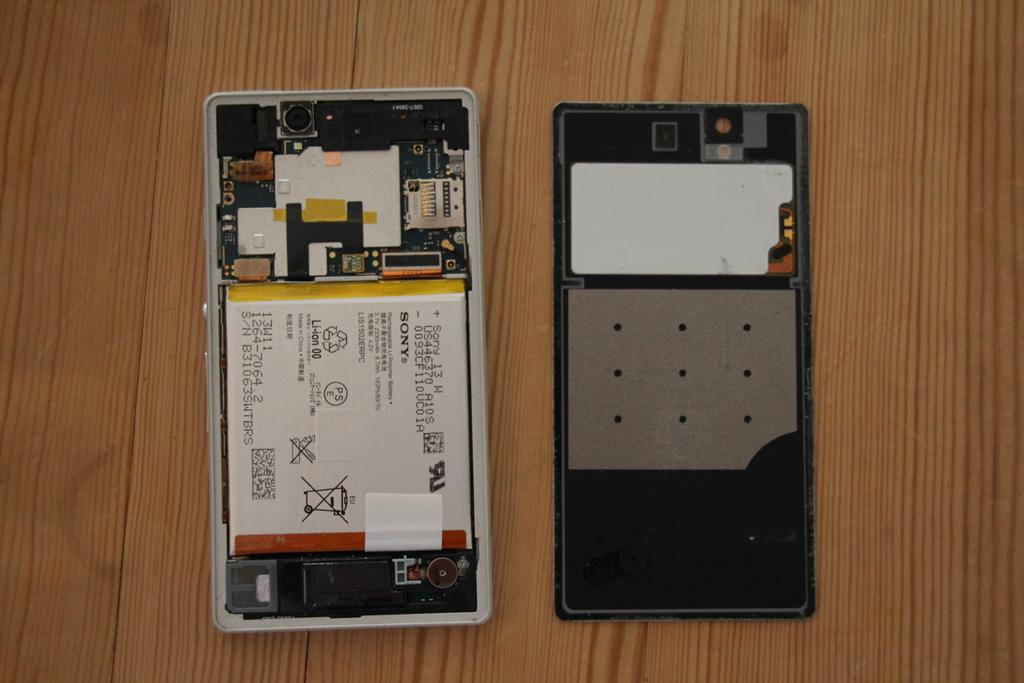What is the brand of battery?
Make the answer very short. Sony. What is the serial number of the battery?
Provide a succinct answer. B31063swtbrs. 